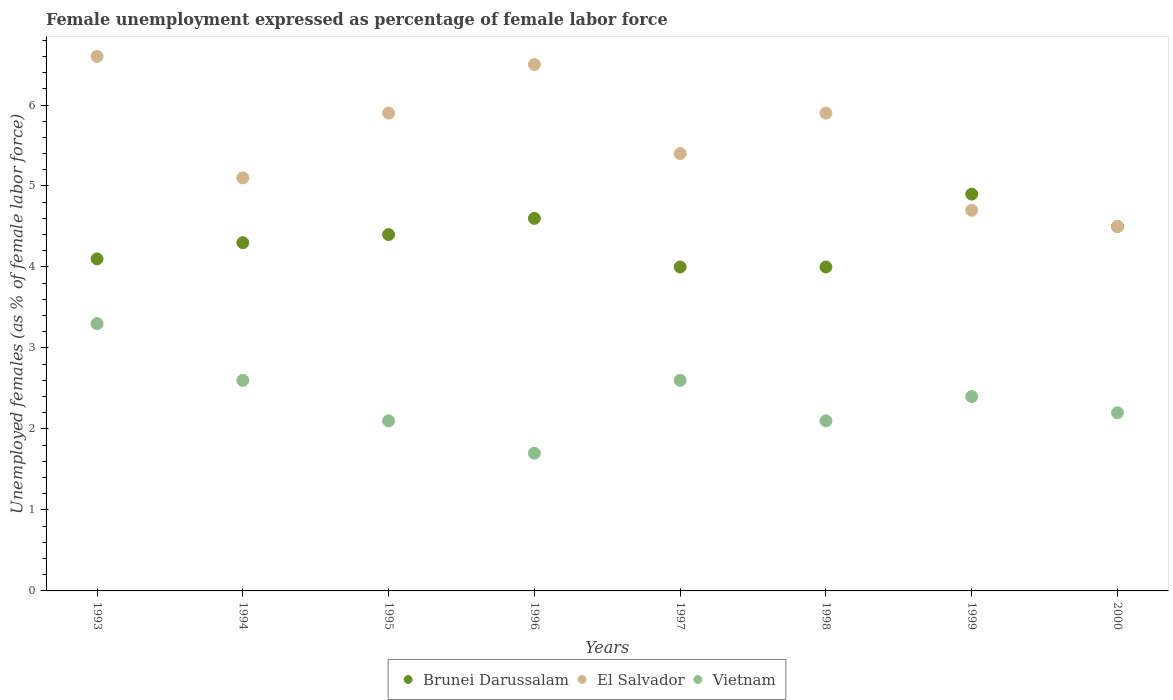What is the unemployment in females in in El Salvador in 2000?
Provide a succinct answer. 4.5. Across all years, what is the maximum unemployment in females in in El Salvador?
Your answer should be very brief. 6.6. What is the total unemployment in females in in Vietnam in the graph?
Your answer should be very brief. 19. What is the difference between the unemployment in females in in El Salvador in 1995 and that in 1997?
Provide a succinct answer. 0.5. What is the difference between the unemployment in females in in El Salvador in 1993 and the unemployment in females in in Brunei Darussalam in 1995?
Give a very brief answer. 2.2. What is the average unemployment in females in in El Salvador per year?
Your answer should be compact. 5.57. In the year 1998, what is the difference between the unemployment in females in in El Salvador and unemployment in females in in Vietnam?
Offer a terse response. 3.8. In how many years, is the unemployment in females in in El Salvador greater than 2.6 %?
Keep it short and to the point. 8. What is the ratio of the unemployment in females in in Vietnam in 1994 to that in 1998?
Keep it short and to the point. 1.24. Is the unemployment in females in in Brunei Darussalam in 1994 less than that in 1995?
Ensure brevity in your answer.  Yes. What is the difference between the highest and the second highest unemployment in females in in Vietnam?
Make the answer very short. 0.7. What is the difference between the highest and the lowest unemployment in females in in El Salvador?
Provide a short and direct response. 2.1. Is the sum of the unemployment in females in in Vietnam in 1994 and 1999 greater than the maximum unemployment in females in in Brunei Darussalam across all years?
Give a very brief answer. Yes. Is it the case that in every year, the sum of the unemployment in females in in El Salvador and unemployment in females in in Vietnam  is greater than the unemployment in females in in Brunei Darussalam?
Offer a terse response. Yes. Does the unemployment in females in in El Salvador monotonically increase over the years?
Ensure brevity in your answer.  No. Is the unemployment in females in in Brunei Darussalam strictly greater than the unemployment in females in in Vietnam over the years?
Provide a short and direct response. Yes. Is the unemployment in females in in Vietnam strictly less than the unemployment in females in in Brunei Darussalam over the years?
Provide a short and direct response. Yes. How many years are there in the graph?
Keep it short and to the point. 8. Does the graph contain any zero values?
Ensure brevity in your answer.  No. How many legend labels are there?
Provide a short and direct response. 3. What is the title of the graph?
Provide a short and direct response. Female unemployment expressed as percentage of female labor force. What is the label or title of the X-axis?
Offer a terse response. Years. What is the label or title of the Y-axis?
Your answer should be compact. Unemployed females (as % of female labor force). What is the Unemployed females (as % of female labor force) in Brunei Darussalam in 1993?
Give a very brief answer. 4.1. What is the Unemployed females (as % of female labor force) in El Salvador in 1993?
Provide a short and direct response. 6.6. What is the Unemployed females (as % of female labor force) of Vietnam in 1993?
Your answer should be compact. 3.3. What is the Unemployed females (as % of female labor force) of Brunei Darussalam in 1994?
Your response must be concise. 4.3. What is the Unemployed females (as % of female labor force) of El Salvador in 1994?
Make the answer very short. 5.1. What is the Unemployed females (as % of female labor force) in Vietnam in 1994?
Ensure brevity in your answer.  2.6. What is the Unemployed females (as % of female labor force) in Brunei Darussalam in 1995?
Offer a terse response. 4.4. What is the Unemployed females (as % of female labor force) of El Salvador in 1995?
Offer a terse response. 5.9. What is the Unemployed females (as % of female labor force) in Vietnam in 1995?
Your answer should be compact. 2.1. What is the Unemployed females (as % of female labor force) of Brunei Darussalam in 1996?
Your answer should be compact. 4.6. What is the Unemployed females (as % of female labor force) of Vietnam in 1996?
Make the answer very short. 1.7. What is the Unemployed females (as % of female labor force) of Brunei Darussalam in 1997?
Your answer should be compact. 4. What is the Unemployed females (as % of female labor force) in El Salvador in 1997?
Offer a terse response. 5.4. What is the Unemployed females (as % of female labor force) of Vietnam in 1997?
Offer a terse response. 2.6. What is the Unemployed females (as % of female labor force) in El Salvador in 1998?
Make the answer very short. 5.9. What is the Unemployed females (as % of female labor force) in Vietnam in 1998?
Your response must be concise. 2.1. What is the Unemployed females (as % of female labor force) of Brunei Darussalam in 1999?
Ensure brevity in your answer.  4.9. What is the Unemployed females (as % of female labor force) of El Salvador in 1999?
Give a very brief answer. 4.7. What is the Unemployed females (as % of female labor force) of Vietnam in 1999?
Ensure brevity in your answer.  2.4. What is the Unemployed females (as % of female labor force) of Brunei Darussalam in 2000?
Offer a terse response. 4.5. What is the Unemployed females (as % of female labor force) in Vietnam in 2000?
Your response must be concise. 2.2. Across all years, what is the maximum Unemployed females (as % of female labor force) in Brunei Darussalam?
Offer a terse response. 4.9. Across all years, what is the maximum Unemployed females (as % of female labor force) of El Salvador?
Make the answer very short. 6.6. Across all years, what is the maximum Unemployed females (as % of female labor force) in Vietnam?
Offer a very short reply. 3.3. Across all years, what is the minimum Unemployed females (as % of female labor force) of Vietnam?
Your response must be concise. 1.7. What is the total Unemployed females (as % of female labor force) of Brunei Darussalam in the graph?
Your response must be concise. 34.8. What is the total Unemployed females (as % of female labor force) in El Salvador in the graph?
Provide a succinct answer. 44.6. What is the total Unemployed females (as % of female labor force) in Vietnam in the graph?
Ensure brevity in your answer.  19. What is the difference between the Unemployed females (as % of female labor force) in Brunei Darussalam in 1993 and that in 1994?
Give a very brief answer. -0.2. What is the difference between the Unemployed females (as % of female labor force) in El Salvador in 1993 and that in 1994?
Make the answer very short. 1.5. What is the difference between the Unemployed females (as % of female labor force) in Brunei Darussalam in 1993 and that in 1995?
Your answer should be compact. -0.3. What is the difference between the Unemployed females (as % of female labor force) of El Salvador in 1993 and that in 1995?
Keep it short and to the point. 0.7. What is the difference between the Unemployed females (as % of female labor force) in El Salvador in 1993 and that in 1996?
Provide a succinct answer. 0.1. What is the difference between the Unemployed females (as % of female labor force) in Vietnam in 1993 and that in 1996?
Your answer should be compact. 1.6. What is the difference between the Unemployed females (as % of female labor force) of El Salvador in 1993 and that in 1999?
Provide a succinct answer. 1.9. What is the difference between the Unemployed females (as % of female labor force) in Brunei Darussalam in 1993 and that in 2000?
Offer a terse response. -0.4. What is the difference between the Unemployed females (as % of female labor force) of Brunei Darussalam in 1994 and that in 1995?
Your answer should be compact. -0.1. What is the difference between the Unemployed females (as % of female labor force) of Vietnam in 1994 and that in 1995?
Provide a short and direct response. 0.5. What is the difference between the Unemployed females (as % of female labor force) in Vietnam in 1994 and that in 1997?
Offer a very short reply. 0. What is the difference between the Unemployed females (as % of female labor force) in Brunei Darussalam in 1994 and that in 1998?
Your answer should be very brief. 0.3. What is the difference between the Unemployed females (as % of female labor force) of Vietnam in 1994 and that in 1999?
Give a very brief answer. 0.2. What is the difference between the Unemployed females (as % of female labor force) of Brunei Darussalam in 1994 and that in 2000?
Provide a succinct answer. -0.2. What is the difference between the Unemployed females (as % of female labor force) of El Salvador in 1994 and that in 2000?
Offer a very short reply. 0.6. What is the difference between the Unemployed females (as % of female labor force) in Vietnam in 1994 and that in 2000?
Your answer should be very brief. 0.4. What is the difference between the Unemployed females (as % of female labor force) in El Salvador in 1995 and that in 1996?
Keep it short and to the point. -0.6. What is the difference between the Unemployed females (as % of female labor force) of Vietnam in 1995 and that in 1996?
Ensure brevity in your answer.  0.4. What is the difference between the Unemployed females (as % of female labor force) in Brunei Darussalam in 1995 and that in 1997?
Provide a succinct answer. 0.4. What is the difference between the Unemployed females (as % of female labor force) in Vietnam in 1995 and that in 1997?
Provide a succinct answer. -0.5. What is the difference between the Unemployed females (as % of female labor force) in El Salvador in 1995 and that in 2000?
Offer a terse response. 1.4. What is the difference between the Unemployed females (as % of female labor force) in Vietnam in 1995 and that in 2000?
Make the answer very short. -0.1. What is the difference between the Unemployed females (as % of female labor force) in Brunei Darussalam in 1996 and that in 1997?
Ensure brevity in your answer.  0.6. What is the difference between the Unemployed females (as % of female labor force) in Brunei Darussalam in 1996 and that in 1998?
Make the answer very short. 0.6. What is the difference between the Unemployed females (as % of female labor force) in Vietnam in 1996 and that in 1999?
Your response must be concise. -0.7. What is the difference between the Unemployed females (as % of female labor force) of Brunei Darussalam in 1996 and that in 2000?
Keep it short and to the point. 0.1. What is the difference between the Unemployed females (as % of female labor force) of El Salvador in 1996 and that in 2000?
Give a very brief answer. 2. What is the difference between the Unemployed females (as % of female labor force) of Vietnam in 1996 and that in 2000?
Your response must be concise. -0.5. What is the difference between the Unemployed females (as % of female labor force) in Brunei Darussalam in 1997 and that in 1999?
Your answer should be compact. -0.9. What is the difference between the Unemployed females (as % of female labor force) in El Salvador in 1997 and that in 1999?
Provide a short and direct response. 0.7. What is the difference between the Unemployed females (as % of female labor force) in El Salvador in 1997 and that in 2000?
Provide a short and direct response. 0.9. What is the difference between the Unemployed females (as % of female labor force) of Vietnam in 1997 and that in 2000?
Keep it short and to the point. 0.4. What is the difference between the Unemployed females (as % of female labor force) of Brunei Darussalam in 1998 and that in 1999?
Your answer should be compact. -0.9. What is the difference between the Unemployed females (as % of female labor force) of Brunei Darussalam in 1998 and that in 2000?
Keep it short and to the point. -0.5. What is the difference between the Unemployed females (as % of female labor force) of Brunei Darussalam in 1999 and that in 2000?
Ensure brevity in your answer.  0.4. What is the difference between the Unemployed females (as % of female labor force) in Brunei Darussalam in 1993 and the Unemployed females (as % of female labor force) in El Salvador in 1994?
Offer a very short reply. -1. What is the difference between the Unemployed females (as % of female labor force) in El Salvador in 1993 and the Unemployed females (as % of female labor force) in Vietnam in 1994?
Keep it short and to the point. 4. What is the difference between the Unemployed females (as % of female labor force) of Brunei Darussalam in 1993 and the Unemployed females (as % of female labor force) of El Salvador in 1995?
Keep it short and to the point. -1.8. What is the difference between the Unemployed females (as % of female labor force) of Brunei Darussalam in 1993 and the Unemployed females (as % of female labor force) of Vietnam in 1996?
Your answer should be compact. 2.4. What is the difference between the Unemployed females (as % of female labor force) of El Salvador in 1993 and the Unemployed females (as % of female labor force) of Vietnam in 1996?
Keep it short and to the point. 4.9. What is the difference between the Unemployed females (as % of female labor force) of Brunei Darussalam in 1993 and the Unemployed females (as % of female labor force) of El Salvador in 1997?
Give a very brief answer. -1.3. What is the difference between the Unemployed females (as % of female labor force) of Brunei Darussalam in 1993 and the Unemployed females (as % of female labor force) of El Salvador in 1998?
Ensure brevity in your answer.  -1.8. What is the difference between the Unemployed females (as % of female labor force) in Brunei Darussalam in 1993 and the Unemployed females (as % of female labor force) in Vietnam in 1998?
Offer a very short reply. 2. What is the difference between the Unemployed females (as % of female labor force) of Brunei Darussalam in 1993 and the Unemployed females (as % of female labor force) of El Salvador in 1999?
Offer a terse response. -0.6. What is the difference between the Unemployed females (as % of female labor force) of El Salvador in 1993 and the Unemployed females (as % of female labor force) of Vietnam in 1999?
Make the answer very short. 4.2. What is the difference between the Unemployed females (as % of female labor force) of Brunei Darussalam in 1993 and the Unemployed females (as % of female labor force) of Vietnam in 2000?
Your response must be concise. 1.9. What is the difference between the Unemployed females (as % of female labor force) of El Salvador in 1993 and the Unemployed females (as % of female labor force) of Vietnam in 2000?
Offer a very short reply. 4.4. What is the difference between the Unemployed females (as % of female labor force) in Brunei Darussalam in 1994 and the Unemployed females (as % of female labor force) in Vietnam in 1995?
Provide a short and direct response. 2.2. What is the difference between the Unemployed females (as % of female labor force) in Brunei Darussalam in 1994 and the Unemployed females (as % of female labor force) in Vietnam in 1997?
Offer a terse response. 1.7. What is the difference between the Unemployed females (as % of female labor force) in Brunei Darussalam in 1994 and the Unemployed females (as % of female labor force) in Vietnam in 1998?
Ensure brevity in your answer.  2.2. What is the difference between the Unemployed females (as % of female labor force) in El Salvador in 1994 and the Unemployed females (as % of female labor force) in Vietnam in 1998?
Give a very brief answer. 3. What is the difference between the Unemployed females (as % of female labor force) in Brunei Darussalam in 1994 and the Unemployed females (as % of female labor force) in El Salvador in 1999?
Offer a terse response. -0.4. What is the difference between the Unemployed females (as % of female labor force) of Brunei Darussalam in 1994 and the Unemployed females (as % of female labor force) of Vietnam in 1999?
Keep it short and to the point. 1.9. What is the difference between the Unemployed females (as % of female labor force) of Brunei Darussalam in 1994 and the Unemployed females (as % of female labor force) of El Salvador in 2000?
Ensure brevity in your answer.  -0.2. What is the difference between the Unemployed females (as % of female labor force) of Brunei Darussalam in 1995 and the Unemployed females (as % of female labor force) of El Salvador in 1996?
Keep it short and to the point. -2.1. What is the difference between the Unemployed females (as % of female labor force) of El Salvador in 1995 and the Unemployed females (as % of female labor force) of Vietnam in 1996?
Keep it short and to the point. 4.2. What is the difference between the Unemployed females (as % of female labor force) in Brunei Darussalam in 1995 and the Unemployed females (as % of female labor force) in El Salvador in 1997?
Your answer should be compact. -1. What is the difference between the Unemployed females (as % of female labor force) in Brunei Darussalam in 1995 and the Unemployed females (as % of female labor force) in El Salvador in 1998?
Offer a terse response. -1.5. What is the difference between the Unemployed females (as % of female labor force) of Brunei Darussalam in 1995 and the Unemployed females (as % of female labor force) of Vietnam in 1998?
Keep it short and to the point. 2.3. What is the difference between the Unemployed females (as % of female labor force) of El Salvador in 1995 and the Unemployed females (as % of female labor force) of Vietnam in 1998?
Offer a very short reply. 3.8. What is the difference between the Unemployed females (as % of female labor force) in Brunei Darussalam in 1995 and the Unemployed females (as % of female labor force) in Vietnam in 1999?
Give a very brief answer. 2. What is the difference between the Unemployed females (as % of female labor force) of Brunei Darussalam in 1995 and the Unemployed females (as % of female labor force) of Vietnam in 2000?
Make the answer very short. 2.2. What is the difference between the Unemployed females (as % of female labor force) in El Salvador in 1995 and the Unemployed females (as % of female labor force) in Vietnam in 2000?
Your answer should be compact. 3.7. What is the difference between the Unemployed females (as % of female labor force) of Brunei Darussalam in 1996 and the Unemployed females (as % of female labor force) of El Salvador in 1998?
Ensure brevity in your answer.  -1.3. What is the difference between the Unemployed females (as % of female labor force) of El Salvador in 1996 and the Unemployed females (as % of female labor force) of Vietnam in 1998?
Make the answer very short. 4.4. What is the difference between the Unemployed females (as % of female labor force) of Brunei Darussalam in 1996 and the Unemployed females (as % of female labor force) of El Salvador in 1999?
Your answer should be very brief. -0.1. What is the difference between the Unemployed females (as % of female labor force) in Brunei Darussalam in 1996 and the Unemployed females (as % of female labor force) in Vietnam in 1999?
Ensure brevity in your answer.  2.2. What is the difference between the Unemployed females (as % of female labor force) of El Salvador in 1996 and the Unemployed females (as % of female labor force) of Vietnam in 1999?
Your answer should be compact. 4.1. What is the difference between the Unemployed females (as % of female labor force) in Brunei Darussalam in 1996 and the Unemployed females (as % of female labor force) in El Salvador in 2000?
Keep it short and to the point. 0.1. What is the difference between the Unemployed females (as % of female labor force) in El Salvador in 1996 and the Unemployed females (as % of female labor force) in Vietnam in 2000?
Give a very brief answer. 4.3. What is the difference between the Unemployed females (as % of female labor force) in El Salvador in 1997 and the Unemployed females (as % of female labor force) in Vietnam in 1999?
Provide a short and direct response. 3. What is the difference between the Unemployed females (as % of female labor force) in Brunei Darussalam in 1997 and the Unemployed females (as % of female labor force) in El Salvador in 2000?
Make the answer very short. -0.5. What is the difference between the Unemployed females (as % of female labor force) of Brunei Darussalam in 1998 and the Unemployed females (as % of female labor force) of El Salvador in 1999?
Provide a succinct answer. -0.7. What is the difference between the Unemployed females (as % of female labor force) in Brunei Darussalam in 1998 and the Unemployed females (as % of female labor force) in Vietnam in 1999?
Give a very brief answer. 1.6. What is the difference between the Unemployed females (as % of female labor force) of El Salvador in 1998 and the Unemployed females (as % of female labor force) of Vietnam in 2000?
Make the answer very short. 3.7. What is the difference between the Unemployed females (as % of female labor force) of Brunei Darussalam in 1999 and the Unemployed females (as % of female labor force) of El Salvador in 2000?
Make the answer very short. 0.4. What is the difference between the Unemployed females (as % of female labor force) of Brunei Darussalam in 1999 and the Unemployed females (as % of female labor force) of Vietnam in 2000?
Offer a terse response. 2.7. What is the difference between the Unemployed females (as % of female labor force) of El Salvador in 1999 and the Unemployed females (as % of female labor force) of Vietnam in 2000?
Offer a terse response. 2.5. What is the average Unemployed females (as % of female labor force) in Brunei Darussalam per year?
Your answer should be compact. 4.35. What is the average Unemployed females (as % of female labor force) in El Salvador per year?
Keep it short and to the point. 5.58. What is the average Unemployed females (as % of female labor force) in Vietnam per year?
Give a very brief answer. 2.38. In the year 1993, what is the difference between the Unemployed females (as % of female labor force) of Brunei Darussalam and Unemployed females (as % of female labor force) of Vietnam?
Provide a succinct answer. 0.8. In the year 1994, what is the difference between the Unemployed females (as % of female labor force) of Brunei Darussalam and Unemployed females (as % of female labor force) of El Salvador?
Offer a terse response. -0.8. In the year 1994, what is the difference between the Unemployed females (as % of female labor force) in Brunei Darussalam and Unemployed females (as % of female labor force) in Vietnam?
Make the answer very short. 1.7. In the year 1995, what is the difference between the Unemployed females (as % of female labor force) in Brunei Darussalam and Unemployed females (as % of female labor force) in El Salvador?
Give a very brief answer. -1.5. In the year 1995, what is the difference between the Unemployed females (as % of female labor force) of Brunei Darussalam and Unemployed females (as % of female labor force) of Vietnam?
Provide a succinct answer. 2.3. In the year 1995, what is the difference between the Unemployed females (as % of female labor force) of El Salvador and Unemployed females (as % of female labor force) of Vietnam?
Offer a terse response. 3.8. In the year 1997, what is the difference between the Unemployed females (as % of female labor force) of Brunei Darussalam and Unemployed females (as % of female labor force) of El Salvador?
Make the answer very short. -1.4. In the year 1997, what is the difference between the Unemployed females (as % of female labor force) of Brunei Darussalam and Unemployed females (as % of female labor force) of Vietnam?
Offer a very short reply. 1.4. In the year 1998, what is the difference between the Unemployed females (as % of female labor force) in Brunei Darussalam and Unemployed females (as % of female labor force) in El Salvador?
Your answer should be very brief. -1.9. In the year 1998, what is the difference between the Unemployed females (as % of female labor force) in Brunei Darussalam and Unemployed females (as % of female labor force) in Vietnam?
Keep it short and to the point. 1.9. In the year 1998, what is the difference between the Unemployed females (as % of female labor force) of El Salvador and Unemployed females (as % of female labor force) of Vietnam?
Offer a terse response. 3.8. In the year 1999, what is the difference between the Unemployed females (as % of female labor force) of Brunei Darussalam and Unemployed females (as % of female labor force) of El Salvador?
Offer a very short reply. 0.2. In the year 1999, what is the difference between the Unemployed females (as % of female labor force) in El Salvador and Unemployed females (as % of female labor force) in Vietnam?
Keep it short and to the point. 2.3. In the year 2000, what is the difference between the Unemployed females (as % of female labor force) of Brunei Darussalam and Unemployed females (as % of female labor force) of El Salvador?
Provide a succinct answer. 0. In the year 2000, what is the difference between the Unemployed females (as % of female labor force) in Brunei Darussalam and Unemployed females (as % of female labor force) in Vietnam?
Your response must be concise. 2.3. In the year 2000, what is the difference between the Unemployed females (as % of female labor force) of El Salvador and Unemployed females (as % of female labor force) of Vietnam?
Give a very brief answer. 2.3. What is the ratio of the Unemployed females (as % of female labor force) in Brunei Darussalam in 1993 to that in 1994?
Your answer should be very brief. 0.95. What is the ratio of the Unemployed females (as % of female labor force) of El Salvador in 1993 to that in 1994?
Ensure brevity in your answer.  1.29. What is the ratio of the Unemployed females (as % of female labor force) in Vietnam in 1993 to that in 1994?
Your answer should be compact. 1.27. What is the ratio of the Unemployed females (as % of female labor force) of Brunei Darussalam in 1993 to that in 1995?
Offer a very short reply. 0.93. What is the ratio of the Unemployed females (as % of female labor force) in El Salvador in 1993 to that in 1995?
Offer a terse response. 1.12. What is the ratio of the Unemployed females (as % of female labor force) of Vietnam in 1993 to that in 1995?
Give a very brief answer. 1.57. What is the ratio of the Unemployed females (as % of female labor force) of Brunei Darussalam in 1993 to that in 1996?
Make the answer very short. 0.89. What is the ratio of the Unemployed females (as % of female labor force) of El Salvador in 1993 to that in 1996?
Provide a short and direct response. 1.02. What is the ratio of the Unemployed females (as % of female labor force) in Vietnam in 1993 to that in 1996?
Your response must be concise. 1.94. What is the ratio of the Unemployed females (as % of female labor force) in Brunei Darussalam in 1993 to that in 1997?
Your answer should be very brief. 1.02. What is the ratio of the Unemployed females (as % of female labor force) of El Salvador in 1993 to that in 1997?
Provide a succinct answer. 1.22. What is the ratio of the Unemployed females (as % of female labor force) of Vietnam in 1993 to that in 1997?
Make the answer very short. 1.27. What is the ratio of the Unemployed females (as % of female labor force) in Brunei Darussalam in 1993 to that in 1998?
Offer a very short reply. 1.02. What is the ratio of the Unemployed females (as % of female labor force) of El Salvador in 1993 to that in 1998?
Make the answer very short. 1.12. What is the ratio of the Unemployed females (as % of female labor force) of Vietnam in 1993 to that in 1998?
Keep it short and to the point. 1.57. What is the ratio of the Unemployed females (as % of female labor force) in Brunei Darussalam in 1993 to that in 1999?
Make the answer very short. 0.84. What is the ratio of the Unemployed females (as % of female labor force) of El Salvador in 1993 to that in 1999?
Your response must be concise. 1.4. What is the ratio of the Unemployed females (as % of female labor force) of Vietnam in 1993 to that in 1999?
Provide a succinct answer. 1.38. What is the ratio of the Unemployed females (as % of female labor force) in Brunei Darussalam in 1993 to that in 2000?
Provide a short and direct response. 0.91. What is the ratio of the Unemployed females (as % of female labor force) of El Salvador in 1993 to that in 2000?
Your response must be concise. 1.47. What is the ratio of the Unemployed females (as % of female labor force) of Brunei Darussalam in 1994 to that in 1995?
Keep it short and to the point. 0.98. What is the ratio of the Unemployed females (as % of female labor force) in El Salvador in 1994 to that in 1995?
Your response must be concise. 0.86. What is the ratio of the Unemployed females (as % of female labor force) in Vietnam in 1994 to that in 1995?
Keep it short and to the point. 1.24. What is the ratio of the Unemployed females (as % of female labor force) of Brunei Darussalam in 1994 to that in 1996?
Ensure brevity in your answer.  0.93. What is the ratio of the Unemployed females (as % of female labor force) of El Salvador in 1994 to that in 1996?
Ensure brevity in your answer.  0.78. What is the ratio of the Unemployed females (as % of female labor force) in Vietnam in 1994 to that in 1996?
Offer a terse response. 1.53. What is the ratio of the Unemployed females (as % of female labor force) in Brunei Darussalam in 1994 to that in 1997?
Give a very brief answer. 1.07. What is the ratio of the Unemployed females (as % of female labor force) in El Salvador in 1994 to that in 1997?
Provide a short and direct response. 0.94. What is the ratio of the Unemployed females (as % of female labor force) in Vietnam in 1994 to that in 1997?
Give a very brief answer. 1. What is the ratio of the Unemployed females (as % of female labor force) of Brunei Darussalam in 1994 to that in 1998?
Your answer should be compact. 1.07. What is the ratio of the Unemployed females (as % of female labor force) in El Salvador in 1994 to that in 1998?
Your answer should be compact. 0.86. What is the ratio of the Unemployed females (as % of female labor force) in Vietnam in 1994 to that in 1998?
Offer a terse response. 1.24. What is the ratio of the Unemployed females (as % of female labor force) in Brunei Darussalam in 1994 to that in 1999?
Offer a very short reply. 0.88. What is the ratio of the Unemployed females (as % of female labor force) of El Salvador in 1994 to that in 1999?
Offer a very short reply. 1.09. What is the ratio of the Unemployed females (as % of female labor force) in Vietnam in 1994 to that in 1999?
Your answer should be compact. 1.08. What is the ratio of the Unemployed females (as % of female labor force) of Brunei Darussalam in 1994 to that in 2000?
Offer a very short reply. 0.96. What is the ratio of the Unemployed females (as % of female labor force) in El Salvador in 1994 to that in 2000?
Your answer should be compact. 1.13. What is the ratio of the Unemployed females (as % of female labor force) of Vietnam in 1994 to that in 2000?
Make the answer very short. 1.18. What is the ratio of the Unemployed females (as % of female labor force) in Brunei Darussalam in 1995 to that in 1996?
Ensure brevity in your answer.  0.96. What is the ratio of the Unemployed females (as % of female labor force) of El Salvador in 1995 to that in 1996?
Your answer should be compact. 0.91. What is the ratio of the Unemployed females (as % of female labor force) in Vietnam in 1995 to that in 1996?
Keep it short and to the point. 1.24. What is the ratio of the Unemployed females (as % of female labor force) of El Salvador in 1995 to that in 1997?
Your answer should be very brief. 1.09. What is the ratio of the Unemployed females (as % of female labor force) in Vietnam in 1995 to that in 1997?
Offer a very short reply. 0.81. What is the ratio of the Unemployed females (as % of female labor force) of El Salvador in 1995 to that in 1998?
Your answer should be compact. 1. What is the ratio of the Unemployed females (as % of female labor force) in Vietnam in 1995 to that in 1998?
Your answer should be compact. 1. What is the ratio of the Unemployed females (as % of female labor force) of Brunei Darussalam in 1995 to that in 1999?
Your answer should be compact. 0.9. What is the ratio of the Unemployed females (as % of female labor force) of El Salvador in 1995 to that in 1999?
Ensure brevity in your answer.  1.26. What is the ratio of the Unemployed females (as % of female labor force) of Brunei Darussalam in 1995 to that in 2000?
Ensure brevity in your answer.  0.98. What is the ratio of the Unemployed females (as % of female labor force) of El Salvador in 1995 to that in 2000?
Give a very brief answer. 1.31. What is the ratio of the Unemployed females (as % of female labor force) in Vietnam in 1995 to that in 2000?
Give a very brief answer. 0.95. What is the ratio of the Unemployed females (as % of female labor force) of Brunei Darussalam in 1996 to that in 1997?
Your response must be concise. 1.15. What is the ratio of the Unemployed females (as % of female labor force) of El Salvador in 1996 to that in 1997?
Offer a very short reply. 1.2. What is the ratio of the Unemployed females (as % of female labor force) in Vietnam in 1996 to that in 1997?
Your answer should be compact. 0.65. What is the ratio of the Unemployed females (as % of female labor force) of Brunei Darussalam in 1996 to that in 1998?
Your answer should be very brief. 1.15. What is the ratio of the Unemployed females (as % of female labor force) in El Salvador in 1996 to that in 1998?
Your answer should be compact. 1.1. What is the ratio of the Unemployed females (as % of female labor force) of Vietnam in 1996 to that in 1998?
Your response must be concise. 0.81. What is the ratio of the Unemployed females (as % of female labor force) of Brunei Darussalam in 1996 to that in 1999?
Give a very brief answer. 0.94. What is the ratio of the Unemployed females (as % of female labor force) of El Salvador in 1996 to that in 1999?
Your answer should be very brief. 1.38. What is the ratio of the Unemployed females (as % of female labor force) in Vietnam in 1996 to that in 1999?
Make the answer very short. 0.71. What is the ratio of the Unemployed females (as % of female labor force) of Brunei Darussalam in 1996 to that in 2000?
Provide a short and direct response. 1.02. What is the ratio of the Unemployed females (as % of female labor force) of El Salvador in 1996 to that in 2000?
Ensure brevity in your answer.  1.44. What is the ratio of the Unemployed females (as % of female labor force) of Vietnam in 1996 to that in 2000?
Your answer should be compact. 0.77. What is the ratio of the Unemployed females (as % of female labor force) in Brunei Darussalam in 1997 to that in 1998?
Your response must be concise. 1. What is the ratio of the Unemployed females (as % of female labor force) of El Salvador in 1997 to that in 1998?
Ensure brevity in your answer.  0.92. What is the ratio of the Unemployed females (as % of female labor force) of Vietnam in 1997 to that in 1998?
Give a very brief answer. 1.24. What is the ratio of the Unemployed females (as % of female labor force) in Brunei Darussalam in 1997 to that in 1999?
Your answer should be very brief. 0.82. What is the ratio of the Unemployed females (as % of female labor force) in El Salvador in 1997 to that in 1999?
Your answer should be compact. 1.15. What is the ratio of the Unemployed females (as % of female labor force) in Brunei Darussalam in 1997 to that in 2000?
Offer a very short reply. 0.89. What is the ratio of the Unemployed females (as % of female labor force) in Vietnam in 1997 to that in 2000?
Make the answer very short. 1.18. What is the ratio of the Unemployed females (as % of female labor force) in Brunei Darussalam in 1998 to that in 1999?
Give a very brief answer. 0.82. What is the ratio of the Unemployed females (as % of female labor force) in El Salvador in 1998 to that in 1999?
Your response must be concise. 1.26. What is the ratio of the Unemployed females (as % of female labor force) in Brunei Darussalam in 1998 to that in 2000?
Make the answer very short. 0.89. What is the ratio of the Unemployed females (as % of female labor force) in El Salvador in 1998 to that in 2000?
Give a very brief answer. 1.31. What is the ratio of the Unemployed females (as % of female labor force) of Vietnam in 1998 to that in 2000?
Make the answer very short. 0.95. What is the ratio of the Unemployed females (as % of female labor force) in Brunei Darussalam in 1999 to that in 2000?
Keep it short and to the point. 1.09. What is the ratio of the Unemployed females (as % of female labor force) in El Salvador in 1999 to that in 2000?
Provide a succinct answer. 1.04. What is the difference between the highest and the second highest Unemployed females (as % of female labor force) of Brunei Darussalam?
Your answer should be compact. 0.3. What is the difference between the highest and the second highest Unemployed females (as % of female labor force) of El Salvador?
Ensure brevity in your answer.  0.1. What is the difference between the highest and the lowest Unemployed females (as % of female labor force) of Brunei Darussalam?
Ensure brevity in your answer.  0.9. What is the difference between the highest and the lowest Unemployed females (as % of female labor force) of El Salvador?
Your response must be concise. 2.1. What is the difference between the highest and the lowest Unemployed females (as % of female labor force) in Vietnam?
Your answer should be very brief. 1.6. 